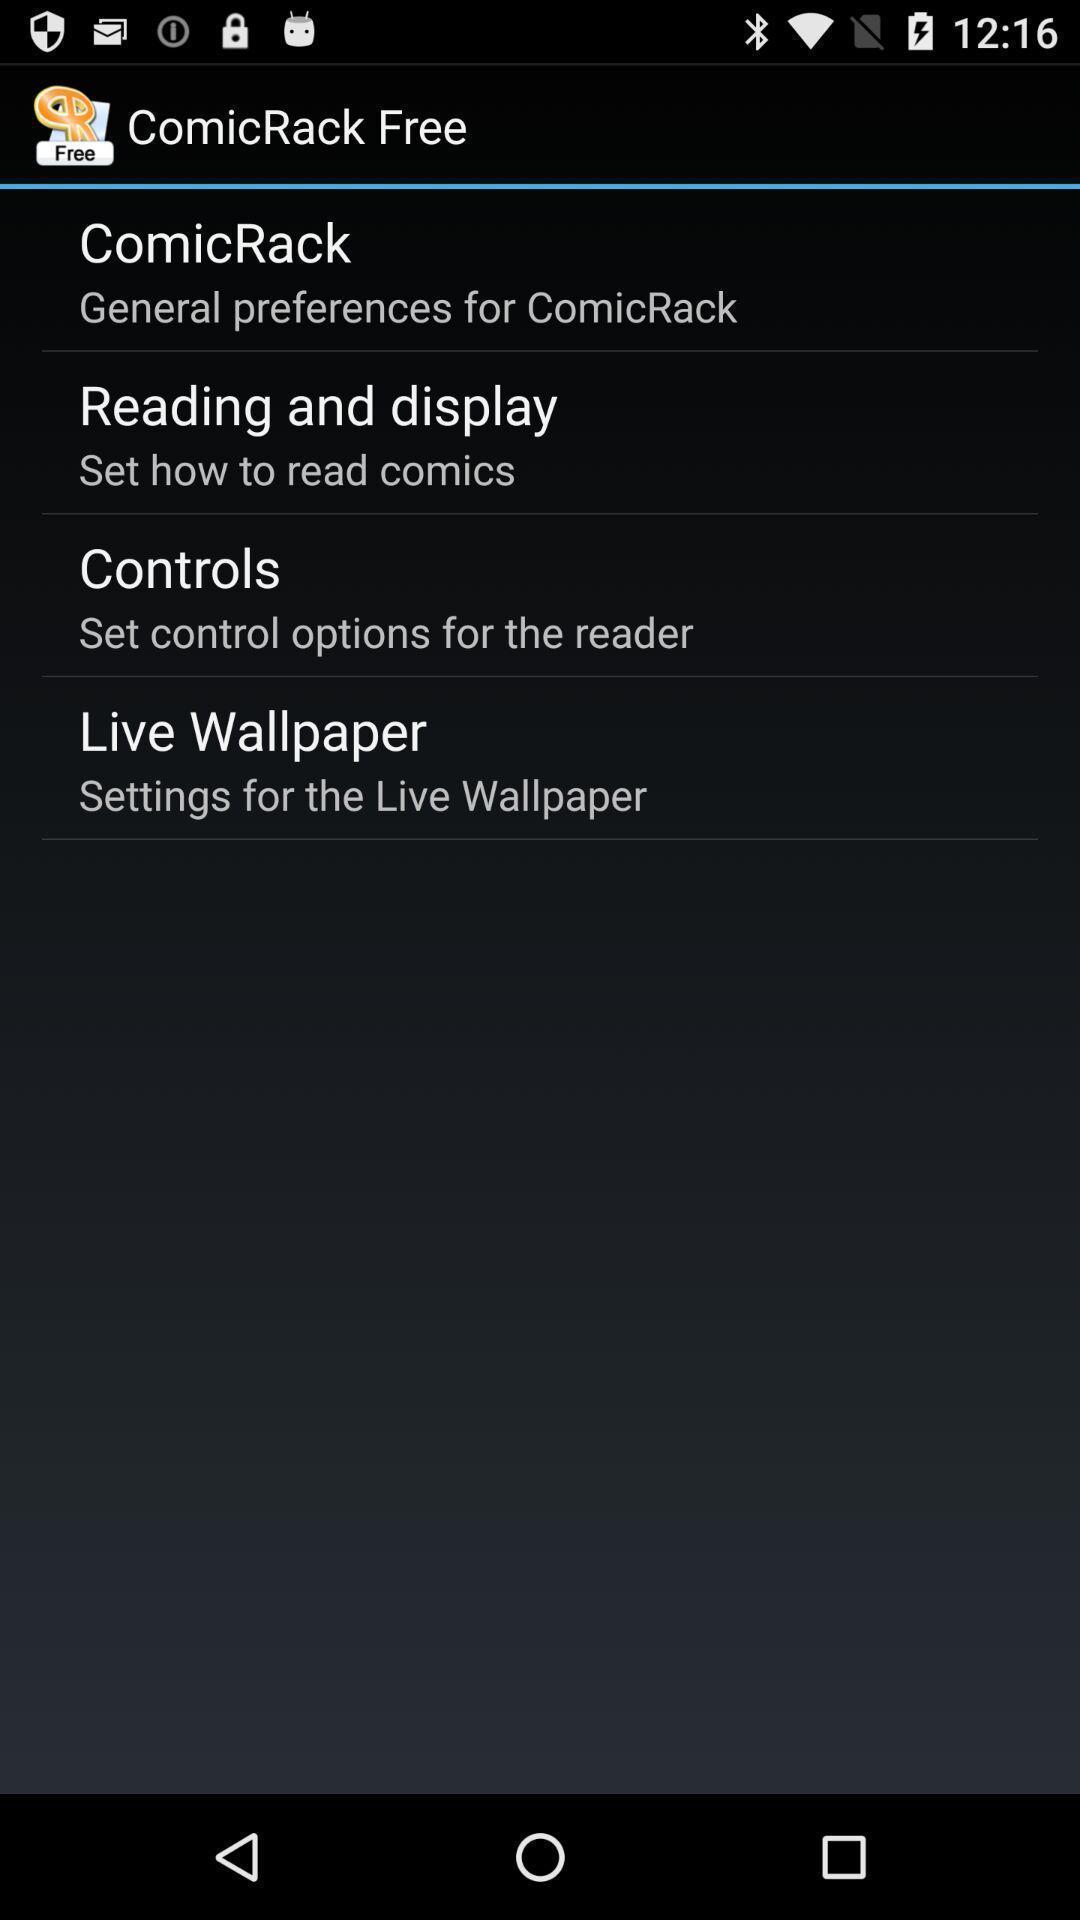Provide a description of this screenshot. Page showing different options. 